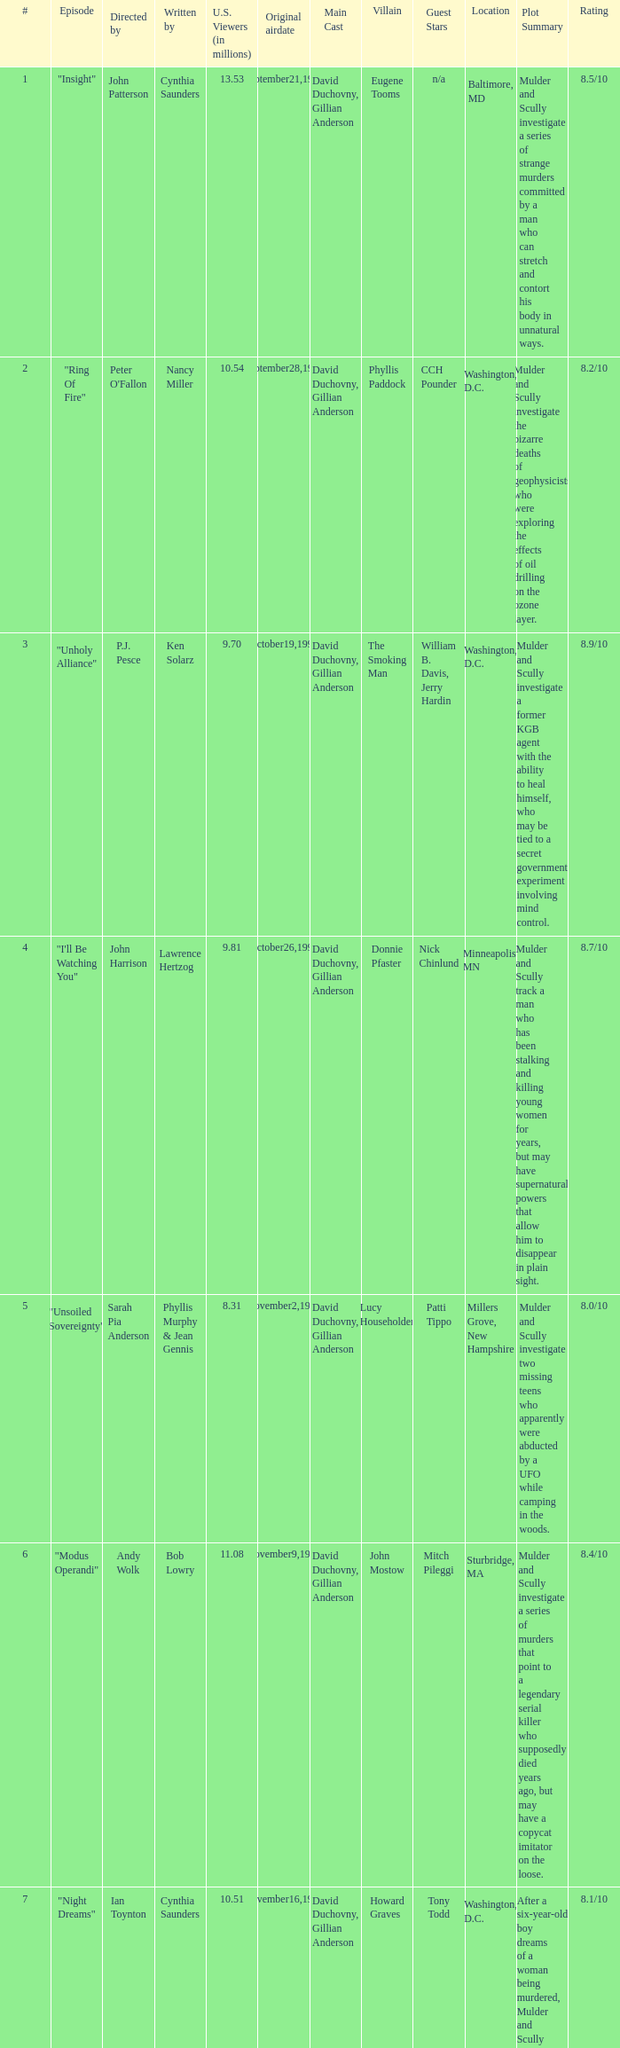Who wrote the episode with 9.81 million US viewers? Lawrence Hertzog. Parse the table in full. {'header': ['#', 'Episode', 'Directed by', 'Written by', 'U.S. Viewers (in millions)', 'Original airdate', 'Main Cast', 'Villain', 'Guest Stars', 'Location', 'Plot Summary', 'Rating'], 'rows': [['1', '"Insight"', 'John Patterson', 'Cynthia Saunders', '13.53', 'September21,1996', 'David Duchovny, Gillian Anderson', 'Eugene Tooms', 'n/a', 'Baltimore, MD', 'Mulder and Scully investigate a series of strange murders committed by a man who can stretch and contort his body in unnatural ways.', '8.5/10'], ['2', '"Ring Of Fire"', "Peter O'Fallon", 'Nancy Miller', '10.54', 'September28,1996', 'David Duchovny, Gillian Anderson', 'Phyllis Paddock', 'CCH Pounder', 'Washington, D.C.', 'Mulder and Scully investigate the bizarre deaths of geophysicists who were exploring the effects of oil drilling on the ozone layer.', '8.2/10'], ['3', '"Unholy Alliance"', 'P.J. Pesce', 'Ken Solarz', '9.70', 'October19,1996', 'David Duchovny, Gillian Anderson', 'The Smoking Man', 'William B. Davis, Jerry Hardin', 'Washington, D.C.', 'Mulder and Scully investigate a former KGB agent with the ability to heal himself, who may be tied to a secret government experiment involving mind control.', '8.9/10'], ['4', '"I\'ll Be Watching You"', 'John Harrison', 'Lawrence Hertzog', '9.81', 'October26,1996', 'David Duchovny, Gillian Anderson', 'Donnie Pfaster', 'Nick Chinlund', 'Minneapolis, MN', 'Mulder and Scully track a man who has been stalking and killing young women for years, but may have supernatural powers that allow him to disappear in plain sight.', '8.7/10'], ['5', '"Unsoiled Sovereignty"', 'Sarah Pia Anderson', 'Phyllis Murphy & Jean Gennis', '8.31', 'November2,1996', 'David Duchovny, Gillian Anderson', 'Lucy Householder', 'Patti Tippo', 'Millers Grove, New Hampshire', 'Mulder and Scully investigate two missing teens who apparently were abducted by a UFO while camping in the woods.', '8.0/10'], ['6', '"Modus Operandi"', 'Andy Wolk', 'Bob Lowry', '11.08', 'November9,1996', 'David Duchovny, Gillian Anderson', 'John Mostow', 'Mitch Pileggi', 'Sturbridge, MA', 'Mulder and Scully investigate a series of murders that point to a legendary serial killer who supposedly died years ago, but may have a copycat imitator on the loose.', '8.4/10'], ['7', '"Night Dreams"', 'Ian Toynton', 'Cynthia Saunders', '10.51', 'November16,1996', 'David Duchovny, Gillian Anderson', 'Howard Graves', 'Tony Todd', 'Washington, D.C.', "After a six-year-old boy dreams of a woman being murdered, Mulder and Scully are called in to investigate when the actual murder occurs and the suspect may be capable of entering people's dreams.", '8.1/10'], ['8', '"Cruel and Unusual"', 'Ian Sander', 'Sibyl Sander', '10.13', 'December14,1996', 'David Duchovny, Gillian Anderson', 'Robert Dorlund', 'Michael Massee', 'Terra Haute, IN', "Mulder and Scully investigate the case of a man who was sentenced to death for the murder of three people, but may have been framed by a genius criminal profiler who can implant false memories in people's minds.", '8.6/10'], ['9', '"The Sorcerer\'s Apprentice"', 'Lewis Teague', 'Ken Solarz', '9.40', 'January4,1997', 'David Duchovny, Gillian Anderson', 'Carl Wade', 'Nestor Serrano', 'Wichita, KS', 'Mulder and Scully are called in to help a detective who is convinced that a series of murders in his jurisdiction are the work of a 1903 serial killer who claimed to be possessed by a demon, and may have returned to finish what he started.', '8.3/10'], ['10', '"Shattered Silence"', 'Sarah Pia Anderson', 'George Geiger', '9.50', 'January11,1997', 'David Duchovny, Gillian Anderson', 'Marty Glenn', 'Bruce Weitz', 'Syracuse, NY', 'When a young woman is found dead in a movie theater, Mulder and Scully discover that the town has been plagued by a string of unsolved murders that may be the work of a ghost or poltergeist.', '7.9/10'], ['11', '"Doppelganger"', 'John Patterson', 'Bob Lowry', '10.12', 'January18,1997', 'David Duchovny, Gillian Anderson', 'Cyclops', 'Jay Underwood', 'Hartford, CT', 'Mulder and Scully investigate a rash of suicides that may be connected to a computer program that creates virtual reality doubles of people.', '8.5/10'], ['12', '"Learning From the Masters"', 'Kevin Hooks', 'Jean Gennis & Phyllis Murphy', '7.89', 'February1,1997', 'David Duchovny, Gillian Anderson', 'Leonard Betts', 'Paul McCrane', 'Washington, D.C.', "When a cancer-ridden man's tumor is removed, it comes to life and refuses to let him die, leading Mulder and Scully on a search for a doctor who can cure any disease.", '8.7/10'], ['13', '"The House that Jack Built"', 'Carl Schenkel', 'Lawrence Hertzog', '8.28', 'February8,1997', 'David Duchovny, Gillian Anderson', 'Jack', 'Chris Ellis', 'Minneapolis, MN', 'After a boy is kidnapped by a man who built a house in the middle of nowhere, Mulder and Scully follow his trail to a madman who believes that he can build a utopia by transforming people into his own image.', '8.0/10'], ['14', '"Shadow Of Angels (Part 1)"', 'John Patterson', 'Sibyl Gardner', '9.34', 'February15,1997', 'David Duchovny, Gillian Anderson', 'Dr. Michael Masser', 'Peter Outerbridge', 'San Diego, CA', 'Mulder and Scully investigate a strange illness that may be caused by experimental drugs given to Gulf War veterans, and find themselves fighting against a powerful pharmaceutical company that will do anything to keep the truth hidden.', '8.5/10'], ['15', '"Shadow Of Angels (Part 2)"', 'Kevin Hooks', 'Charles D. Holland', '9.56', 'February15,1997', 'David Duchovny, Gillian Anderson', 'Dr. Michael Masser', 'Peter Outerbridge', 'San Diego, CA', "Mulder and Scully continue their investigation into the pharmaceutical company's cover-up and discover that the truth may be even darker than they could have imagined.", '8.8/10'], ['16', '"Film At Eleven"', 'Jack Bender', 'Steve Feke', '9.05', 'March8,1997', 'David Duchovny, Gillian Anderson', 'Flukeman', 'Darin Morgan', 'Laurel, MD', "Mulder and Scully investigate a mysterious videotape that shows a young woman's body being dismembered in a hotel room, and find themselves battling a mutant creature that may be behind the murder.", '8.3/10'], ['17', '"Crisis"', 'Matt Penn', 'Bob Lowry', '8.68', 'March22,1997', 'David Duchovny, Gillian Anderson', 'Duane Barry', 'Steve Railsback', 'Washington, D.C.', 'When a former FBI agent takes hostages in a travel agency and demands to talk to Mulder, Scully realizes that the man is the same one who kidnapped her two years earlier and is convinced that aliens are coming to earth.', '9.2/10'], ['18', '"Blue Highway"', 'Michael Pattinson', 'Phyllis Murphy & Jean Gennis', '10.30', 'April5,1997', 'David Duchovny, Gillian Anderson', 'John Barnett', 'Michael Parks', 'North Carolina', 'Mulder and Scully investigate a series of murders that seem to be connected to a love triangle involving a truck driver, a waitress, and a hitchhiker.', '8.6/10'], ['19', '"FTX: Field Training Exercise"', 'Michael Lange', 'George Geiger & Charles D. Holland', '7.52', 'April12,1997', 'David Duchovny, Gillian Anderson', 'n/a', 'n/a', 'Fort Dix, NJ', 'Mulder and Scully go on a field training exercise with a group of FBI agents and find themselves in the middle of a simulation that turns deadly when the agents start to believe that the danger is real.', '7.7/10'], ['20', '"Into the Abyss"', 'Dan Lerner', 'David A. Simons', '8.56', 'April26,1997', 'David Duchovny, Gillian Anderson', 'n/a', 'n/a', 'Gulf of Mexico', 'Mulder and Scully head out to sea to investigate a mysterious death on an oil rig and find themselves battling a sea monster that may be the result of a genetic experiment gone wrong.', '8.1/10'], ['21', '"Venom (Part 1)"', 'James Whitmore Jr.', 'Steve Feke', '8.70', 'May10,1997', 'David Duchovny, Gillian Anderson', 'Marita Covarrubias', 'Laurie Holden', 'West Virginia', 'Mulder and Scully investigate a deadly outbreak of botulism in a small town and discover that a genetically-engineered crop may be to blame.', '8.4/10']]} 